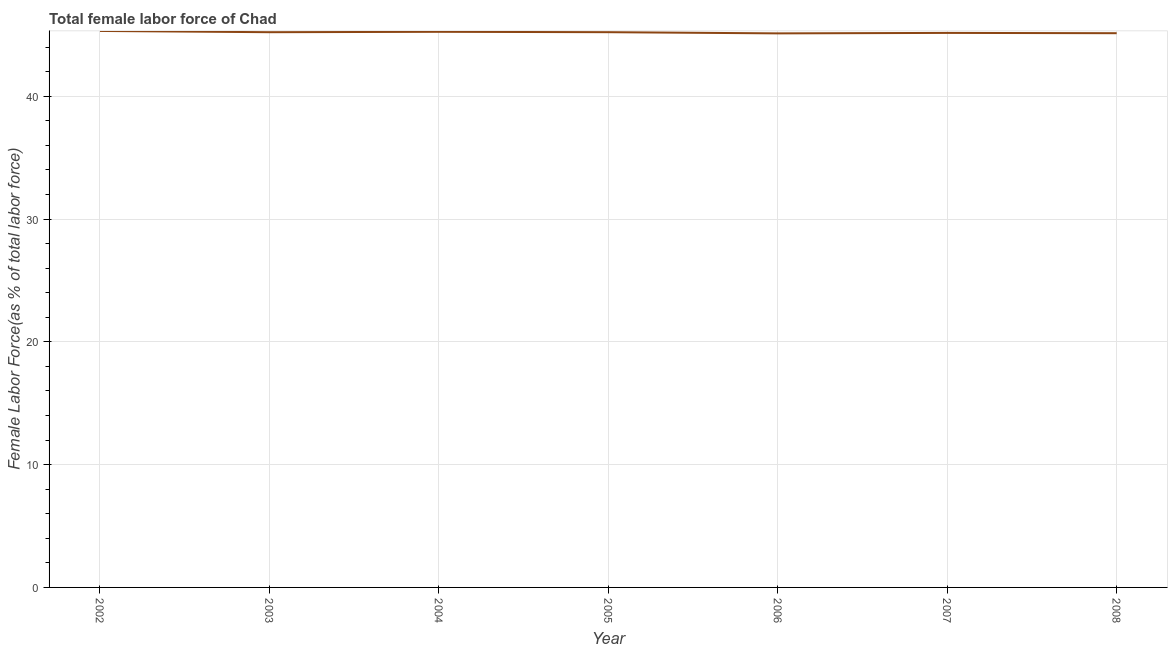What is the total female labor force in 2004?
Give a very brief answer. 45.24. Across all years, what is the maximum total female labor force?
Your response must be concise. 45.31. Across all years, what is the minimum total female labor force?
Provide a succinct answer. 45.12. In which year was the total female labor force maximum?
Your answer should be very brief. 2002. What is the sum of the total female labor force?
Provide a succinct answer. 316.38. What is the difference between the total female labor force in 2003 and 2008?
Offer a very short reply. 0.08. What is the average total female labor force per year?
Your answer should be compact. 45.2. What is the median total female labor force?
Ensure brevity in your answer.  45.21. What is the ratio of the total female labor force in 2003 to that in 2005?
Provide a succinct answer. 1. Is the difference between the total female labor force in 2005 and 2006 greater than the difference between any two years?
Your answer should be very brief. No. What is the difference between the highest and the second highest total female labor force?
Ensure brevity in your answer.  0.07. Is the sum of the total female labor force in 2004 and 2005 greater than the maximum total female labor force across all years?
Offer a terse response. Yes. What is the difference between the highest and the lowest total female labor force?
Make the answer very short. 0.2. In how many years, is the total female labor force greater than the average total female labor force taken over all years?
Offer a terse response. 4. Does the total female labor force monotonically increase over the years?
Provide a short and direct response. No. How many lines are there?
Ensure brevity in your answer.  1. Does the graph contain any zero values?
Your response must be concise. No. What is the title of the graph?
Provide a succinct answer. Total female labor force of Chad. What is the label or title of the X-axis?
Your answer should be very brief. Year. What is the label or title of the Y-axis?
Make the answer very short. Female Labor Force(as % of total labor force). What is the Female Labor Force(as % of total labor force) in 2002?
Ensure brevity in your answer.  45.31. What is the Female Labor Force(as % of total labor force) of 2003?
Give a very brief answer. 45.21. What is the Female Labor Force(as % of total labor force) in 2004?
Your answer should be very brief. 45.24. What is the Female Labor Force(as % of total labor force) of 2005?
Keep it short and to the point. 45.21. What is the Female Labor Force(as % of total labor force) in 2006?
Make the answer very short. 45.12. What is the Female Labor Force(as % of total labor force) of 2007?
Keep it short and to the point. 45.15. What is the Female Labor Force(as % of total labor force) of 2008?
Provide a short and direct response. 45.13. What is the difference between the Female Labor Force(as % of total labor force) in 2002 and 2003?
Ensure brevity in your answer.  0.1. What is the difference between the Female Labor Force(as % of total labor force) in 2002 and 2004?
Offer a very short reply. 0.07. What is the difference between the Female Labor Force(as % of total labor force) in 2002 and 2005?
Your answer should be very brief. 0.1. What is the difference between the Female Labor Force(as % of total labor force) in 2002 and 2006?
Offer a terse response. 0.2. What is the difference between the Female Labor Force(as % of total labor force) in 2002 and 2007?
Ensure brevity in your answer.  0.16. What is the difference between the Female Labor Force(as % of total labor force) in 2002 and 2008?
Your answer should be very brief. 0.18. What is the difference between the Female Labor Force(as % of total labor force) in 2003 and 2004?
Offer a very short reply. -0.03. What is the difference between the Female Labor Force(as % of total labor force) in 2003 and 2005?
Your answer should be very brief. -0. What is the difference between the Female Labor Force(as % of total labor force) in 2003 and 2006?
Your answer should be compact. 0.09. What is the difference between the Female Labor Force(as % of total labor force) in 2003 and 2007?
Your answer should be compact. 0.06. What is the difference between the Female Labor Force(as % of total labor force) in 2003 and 2008?
Your answer should be compact. 0.08. What is the difference between the Female Labor Force(as % of total labor force) in 2004 and 2005?
Keep it short and to the point. 0.03. What is the difference between the Female Labor Force(as % of total labor force) in 2004 and 2006?
Provide a short and direct response. 0.13. What is the difference between the Female Labor Force(as % of total labor force) in 2004 and 2007?
Offer a very short reply. 0.09. What is the difference between the Female Labor Force(as % of total labor force) in 2004 and 2008?
Offer a very short reply. 0.11. What is the difference between the Female Labor Force(as % of total labor force) in 2005 and 2006?
Make the answer very short. 0.1. What is the difference between the Female Labor Force(as % of total labor force) in 2005 and 2007?
Offer a terse response. 0.06. What is the difference between the Female Labor Force(as % of total labor force) in 2005 and 2008?
Give a very brief answer. 0.08. What is the difference between the Female Labor Force(as % of total labor force) in 2006 and 2007?
Your answer should be very brief. -0.04. What is the difference between the Female Labor Force(as % of total labor force) in 2006 and 2008?
Offer a terse response. -0.01. What is the difference between the Female Labor Force(as % of total labor force) in 2007 and 2008?
Make the answer very short. 0.02. What is the ratio of the Female Labor Force(as % of total labor force) in 2002 to that in 2003?
Offer a very short reply. 1. What is the ratio of the Female Labor Force(as % of total labor force) in 2002 to that in 2004?
Offer a very short reply. 1. What is the ratio of the Female Labor Force(as % of total labor force) in 2002 to that in 2005?
Provide a short and direct response. 1. What is the ratio of the Female Labor Force(as % of total labor force) in 2002 to that in 2006?
Provide a short and direct response. 1. What is the ratio of the Female Labor Force(as % of total labor force) in 2003 to that in 2005?
Your answer should be compact. 1. What is the ratio of the Female Labor Force(as % of total labor force) in 2004 to that in 2006?
Provide a succinct answer. 1. What is the ratio of the Female Labor Force(as % of total labor force) in 2004 to that in 2008?
Provide a short and direct response. 1. What is the ratio of the Female Labor Force(as % of total labor force) in 2005 to that in 2006?
Offer a terse response. 1. What is the ratio of the Female Labor Force(as % of total labor force) in 2005 to that in 2007?
Your response must be concise. 1. What is the ratio of the Female Labor Force(as % of total labor force) in 2005 to that in 2008?
Keep it short and to the point. 1. What is the ratio of the Female Labor Force(as % of total labor force) in 2006 to that in 2007?
Provide a short and direct response. 1. What is the ratio of the Female Labor Force(as % of total labor force) in 2006 to that in 2008?
Offer a terse response. 1. What is the ratio of the Female Labor Force(as % of total labor force) in 2007 to that in 2008?
Ensure brevity in your answer.  1. 